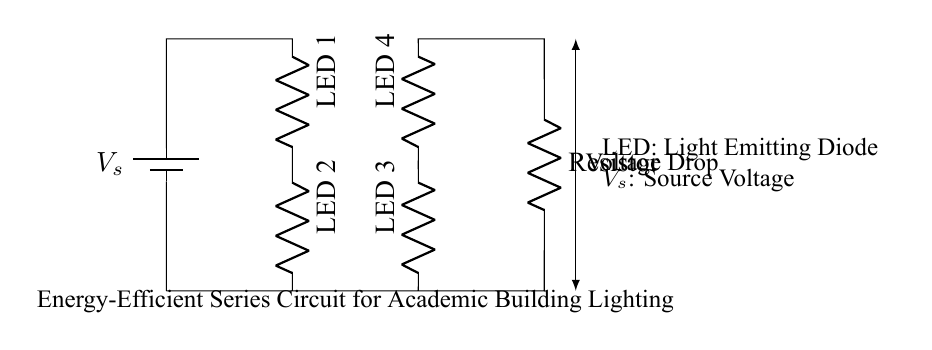What is the total number of LEDs in the circuit? The circuit diagram shows four labeled components that correspond to LEDs. Counting them directly, we see LED 1, LED 2, LED 3, and LED 4.
Answer: Four What is the main power source used in this circuit? The diagram indicates the presence of a battery component labeled as \( V_s \), which serves as the source of voltage for the circuit.
Answer: Battery How are the LEDs connected in the circuit? The LEDs in this circuit are arranged in a series configuration, meaning that they are connected end-to-end, one after the other, allowing current to flow through each one sequentially.
Answer: Series What is the purpose of the resistor in the circuit? Resistors are typically used to limit the current flow in a circuit to protect other components, such as the LEDs. In this case, the resistor helps to control the voltage and current supplied to the LEDs.
Answer: Limit current How will the voltage drop be affected as the current passes through each LED? In a series circuit, the total voltage supplied by the source is divided among all components. Each LED will have a voltage drop proportional to its forward voltage, which means that the voltage drop across each LED will sum to equal the source voltage when they are all turned on.
Answer: Divided What is the role of the battery voltage in the circuit? The source voltage provided by the battery is essential as it drives the current through the entire circuit. Without the source voltage, the current would not flow, and the LEDs wouldn't illuminate. It provides the necessary potential difference to push the current through the circuit.
Answer: Provides current 